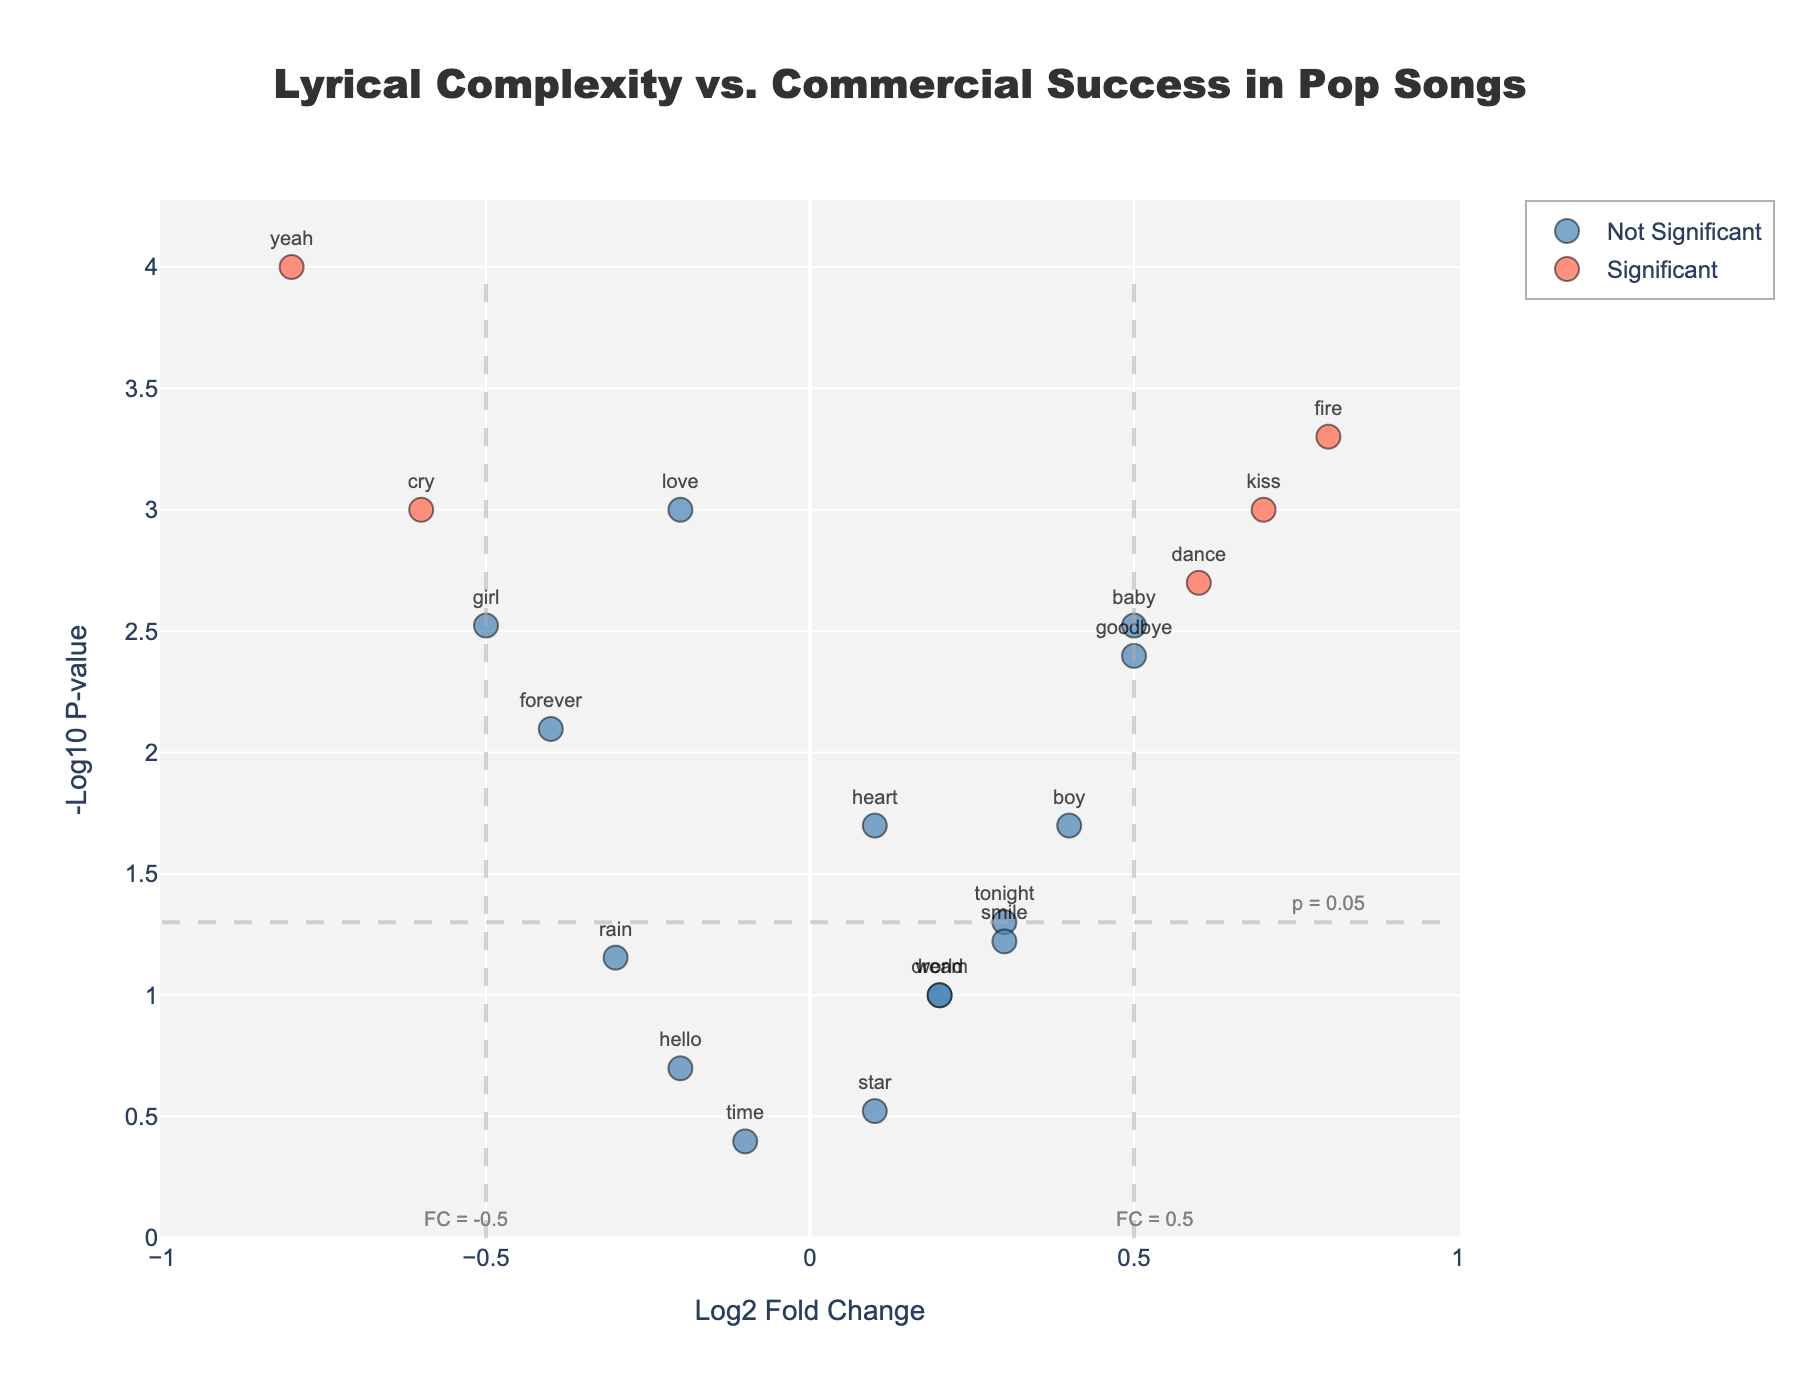What is the title of the figure? The title of the figure can be found at the top center of the figure. It should be prominent and descriptive.
Answer: Lyrical Complexity vs. Commercial Success in Pop Songs How many data points are classified as significant? The data points classified as significant are colored differently (probably as red). Count these highlighted points.
Answer: 10 Which word has the highest log2 fold change? Look for the data point with the highest value on the x-axis (log2 fold change axis).
Answer: fire Which word has the lowest p-value? The word with the lowest p-value will be the one highest on the y-axis (-log10 p-value axis).
Answer: yeah How many words have a log2 fold change greater than 0.5? Locate all data points to the right of the x-axis mark 0.5. Count these points.
Answer: 4 What is the log2 fold change for the word "baby"? Identify the word "baby" on the plot and check its position on the x-axis.
Answer: 0.5 Are most significant words associated with positive or negative log2 fold change? Consider the majority of the significant data points (colored differently) and observe their log2 fold change direction (positive or negative).
Answer: Positive Which word has the highest -log10 p-value among those with a negative log2 fold change? Among the data points on the left side of the y-axis (negative log2 fold change), find the one highest on the y-axis.
Answer: yeah What is the threshold for considering p-values to be significant in this plot? The threshold for significance regarding p-values is depicted by a dashed horizontal line, and its value is annotated.
Answer: 0.05 If a word has a log2 fold change of 0.3 and a p-value of 0.05, is it considered significant? For a word to be significant, its log2 fold change must be beyond ±0.5 and p-value below 0.05. Since 0.3 is less than 0.5, it's not significant.
Answer: No 